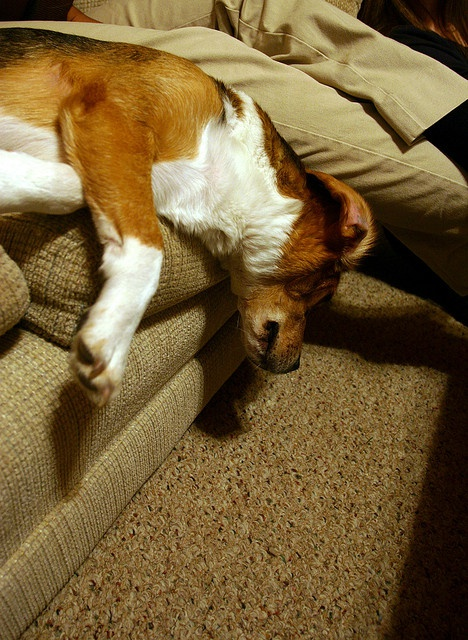Describe the objects in this image and their specific colors. I can see dog in black, olive, beige, and maroon tones, couch in black, olive, and tan tones, and people in black, tan, and olive tones in this image. 